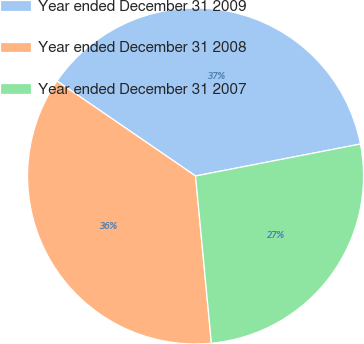Convert chart. <chart><loc_0><loc_0><loc_500><loc_500><pie_chart><fcel>Year ended December 31 2009<fcel>Year ended December 31 2008<fcel>Year ended December 31 2007<nl><fcel>37.38%<fcel>36.07%<fcel>26.54%<nl></chart> 